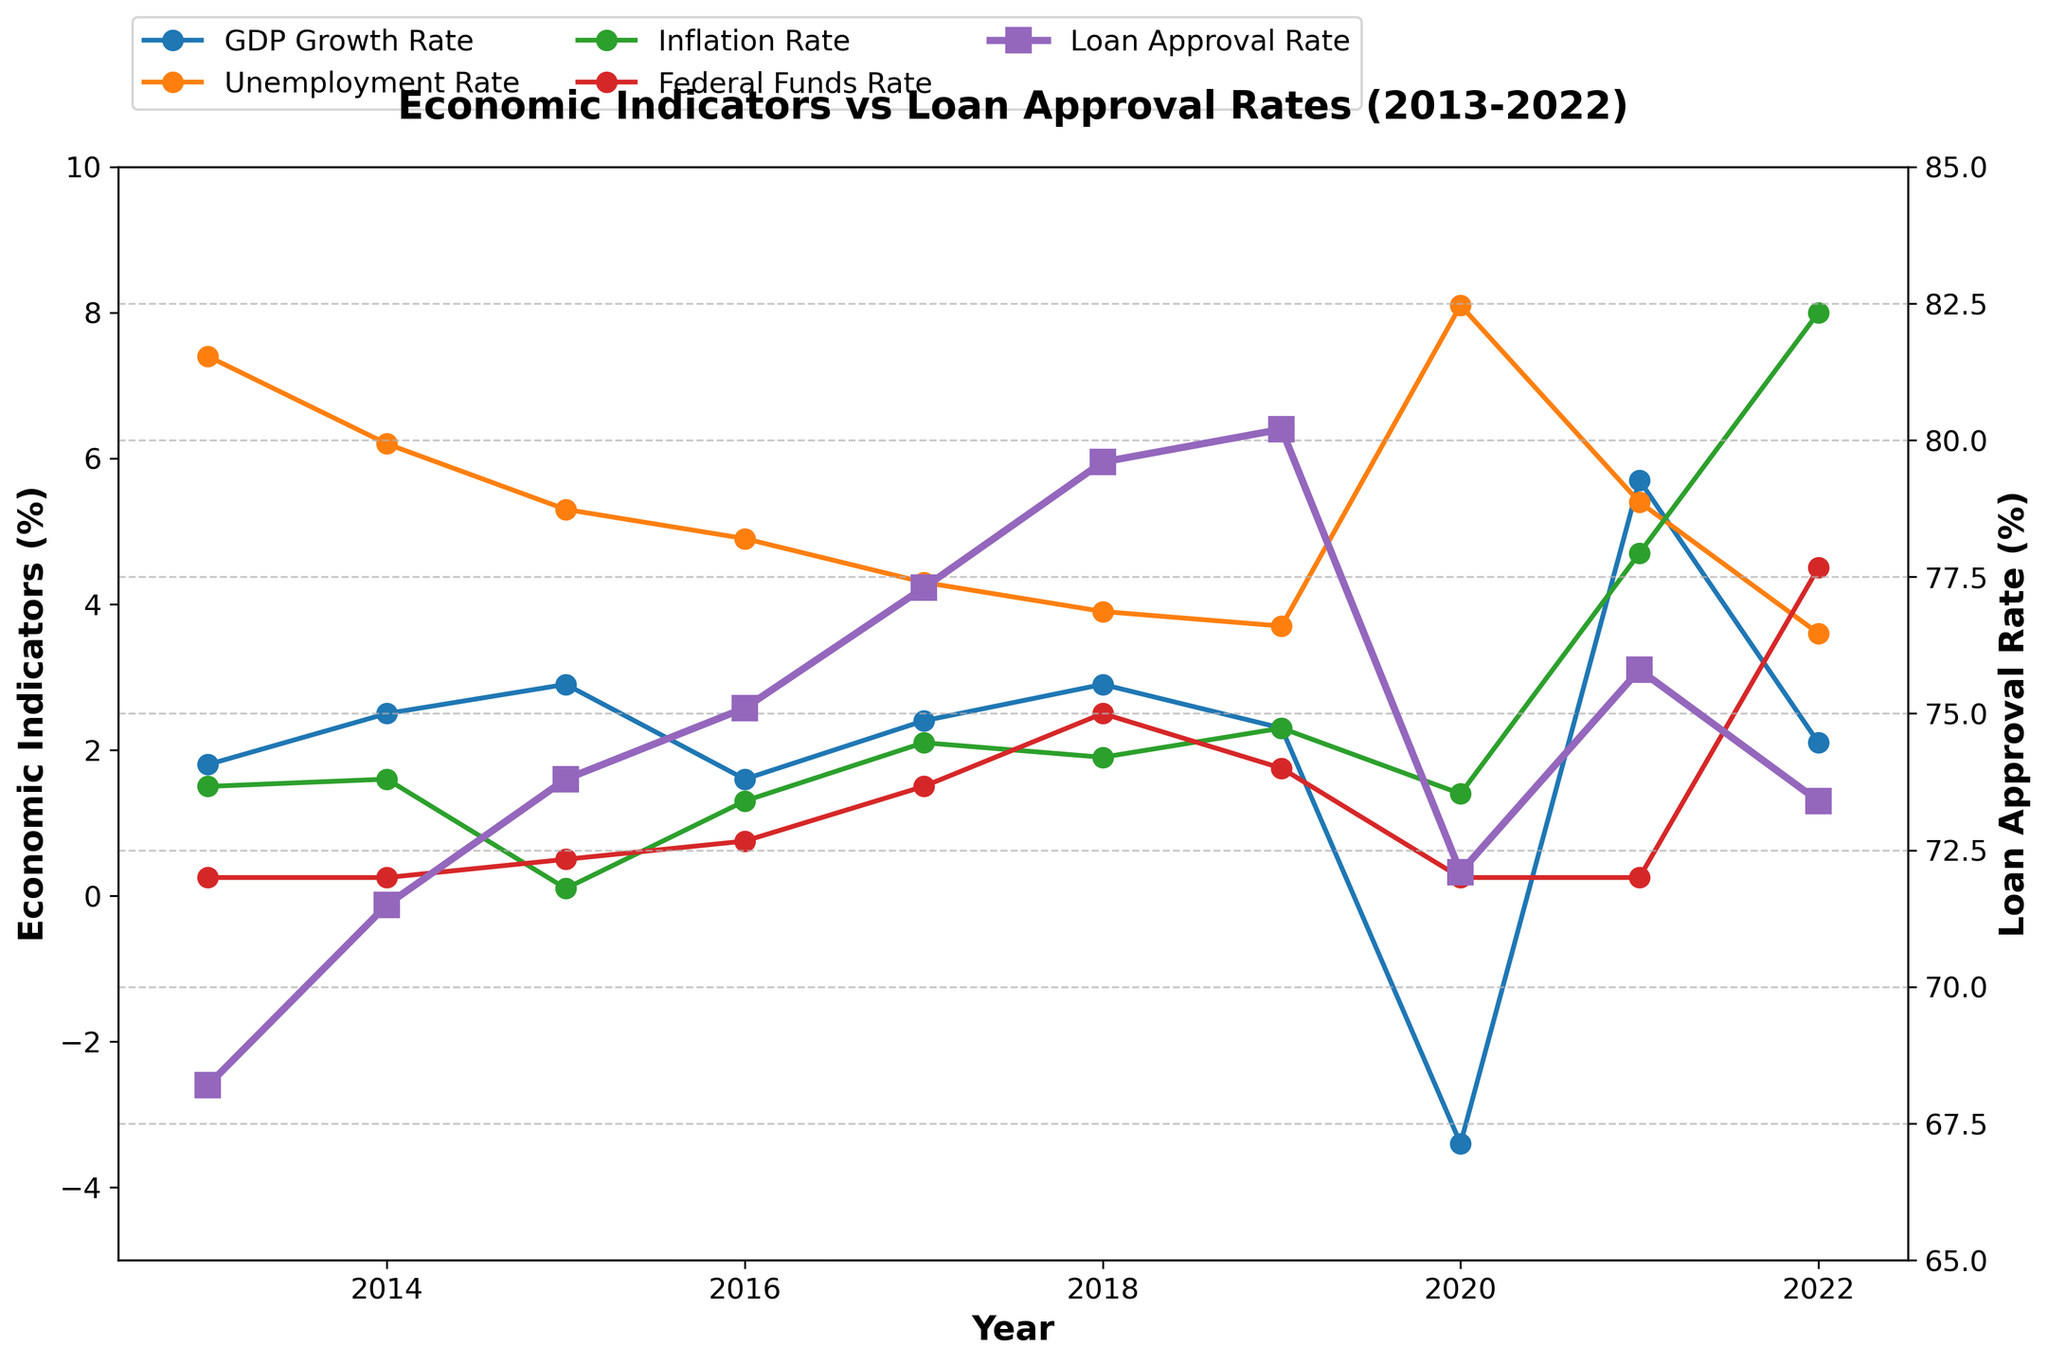What years had the highest and lowest loan approval rates? To find the highest and lowest loan approval rates, look at the peaks and troughs on the Loan Approval Rate line (dark purple). The highest point is in 2019, and the lowest is in 2013.
Answer: 2019, 2013 How did the unemployment rate change from 2019 to 2020? The unemployment rate is displayed in orange. In 2019, it was around 3.7%, and in 2020, it spiked to 8.1%. The difference is 8.1% - 3.7% = 4.4%.
Answer: Increased by 4.4% Was there a year when the inflation rate exceeded the federal funds rate by at least 3%? To check this, compare the green line (Inflation Rate) with the red line (Federal Funds Rate). In 2022, the inflation rate (8.0%) exceeded the federal funds rate (4.5%) by 3.5%.
Answer: Yes, in 2022 Which economic indicator showed a sharp decline during the COVID-19 pandemic in 2020? The year 2020 is marked with a COVID-19 annotation. The blue line (GDP Growth Rate) showed a significant drop from 2.3% in 2019 to -3.4% in 2020.
Answer: GDP Growth Rate What is the trend in the relationship between GDP growth rate and loan approval rate from 2013 to 2022? Looking at the blue line (GDP Growth Rate) and the dark purple line (Loan Approval Rate), both generally increase together, drop during the pandemic in 2020, and then slightly recover. This suggests a positive correlation.
Answer: Positive correlation By how much did the federal funds rate increase from 2021 to 2022? Locate the red line for the Federal Funds Rate. In 2021, it was 0.25%, and in 2022, it spiked to 4.5%. The change is 4.5% - 0.25% = 4.25%.
Answer: 4.25% Which economic indicator legends are plotted on the left y-axis? The left y-axis shows multiple legends (colors: blue, orange, green, red) representing GDP Growth Rate, Unemployment Rate, Inflation Rate, and Federal Funds Rate.
Answer: GDP Growth Rate, Unemployment Rate, Inflation Rate, Federal Funds Rate Compare the GDP growth rate and inflation rate in 2018. Which was higher? For 2018, compare the blue line (GDP Growth Rate) to the green line (Inflation Rate). The GDP growth rate was 2.9%, and the inflation rate was 1.9%. Therefore, the GDP growth rate was higher.
Answer: GDP Growth Rate How did loan approval rates change from 2017 to 2018? Look at the dark purple line (Loan Approval Rate). In 2017, it was 77.3%, and in 2018, it increased to 79.6%. The change is 79.6% - 77.3% = 2.3%.
Answer: Increased by 2.3% What was the inflation rate trend from 2016 to 2022? Observe the green line over the years. The inflation rate was 1.3% in 2016, rising gradually, peaking at 8.0% in 2022. This indicates an overall upward trend.
Answer: Upward trend 